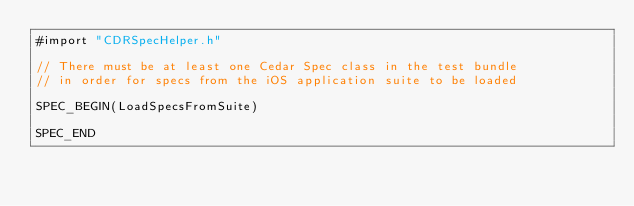<code> <loc_0><loc_0><loc_500><loc_500><_ObjectiveC_>#import "CDRSpecHelper.h"

// There must be at least one Cedar Spec class in the test bundle
// in order for specs from the iOS application suite to be loaded

SPEC_BEGIN(LoadSpecsFromSuite)

SPEC_END
</code> 